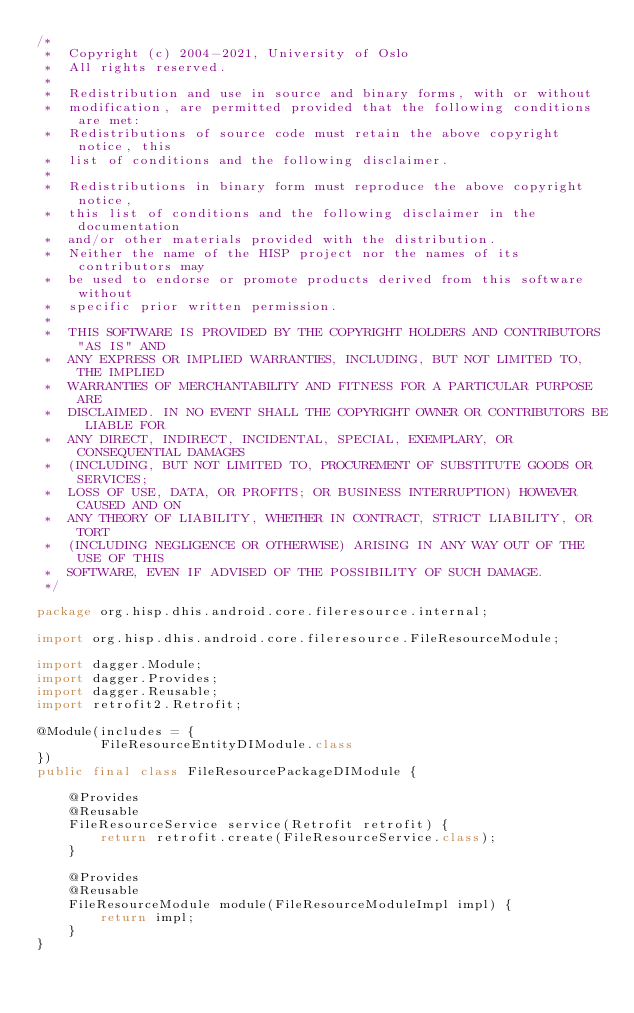<code> <loc_0><loc_0><loc_500><loc_500><_Java_>/*
 *  Copyright (c) 2004-2021, University of Oslo
 *  All rights reserved.
 *
 *  Redistribution and use in source and binary forms, with or without
 *  modification, are permitted provided that the following conditions are met:
 *  Redistributions of source code must retain the above copyright notice, this
 *  list of conditions and the following disclaimer.
 *
 *  Redistributions in binary form must reproduce the above copyright notice,
 *  this list of conditions and the following disclaimer in the documentation
 *  and/or other materials provided with the distribution.
 *  Neither the name of the HISP project nor the names of its contributors may
 *  be used to endorse or promote products derived from this software without
 *  specific prior written permission.
 *
 *  THIS SOFTWARE IS PROVIDED BY THE COPYRIGHT HOLDERS AND CONTRIBUTORS "AS IS" AND
 *  ANY EXPRESS OR IMPLIED WARRANTIES, INCLUDING, BUT NOT LIMITED TO, THE IMPLIED
 *  WARRANTIES OF MERCHANTABILITY AND FITNESS FOR A PARTICULAR PURPOSE ARE
 *  DISCLAIMED. IN NO EVENT SHALL THE COPYRIGHT OWNER OR CONTRIBUTORS BE LIABLE FOR
 *  ANY DIRECT, INDIRECT, INCIDENTAL, SPECIAL, EXEMPLARY, OR CONSEQUENTIAL DAMAGES
 *  (INCLUDING, BUT NOT LIMITED TO, PROCUREMENT OF SUBSTITUTE GOODS OR SERVICES;
 *  LOSS OF USE, DATA, OR PROFITS; OR BUSINESS INTERRUPTION) HOWEVER CAUSED AND ON
 *  ANY THEORY OF LIABILITY, WHETHER IN CONTRACT, STRICT LIABILITY, OR TORT
 *  (INCLUDING NEGLIGENCE OR OTHERWISE) ARISING IN ANY WAY OUT OF THE USE OF THIS
 *  SOFTWARE, EVEN IF ADVISED OF THE POSSIBILITY OF SUCH DAMAGE.
 */

package org.hisp.dhis.android.core.fileresource.internal;

import org.hisp.dhis.android.core.fileresource.FileResourceModule;

import dagger.Module;
import dagger.Provides;
import dagger.Reusable;
import retrofit2.Retrofit;

@Module(includes = {
        FileResourceEntityDIModule.class
})
public final class FileResourcePackageDIModule {

    @Provides
    @Reusable
    FileResourceService service(Retrofit retrofit) {
        return retrofit.create(FileResourceService.class);
    }

    @Provides
    @Reusable
    FileResourceModule module(FileResourceModuleImpl impl) {
        return impl;
    }
}</code> 